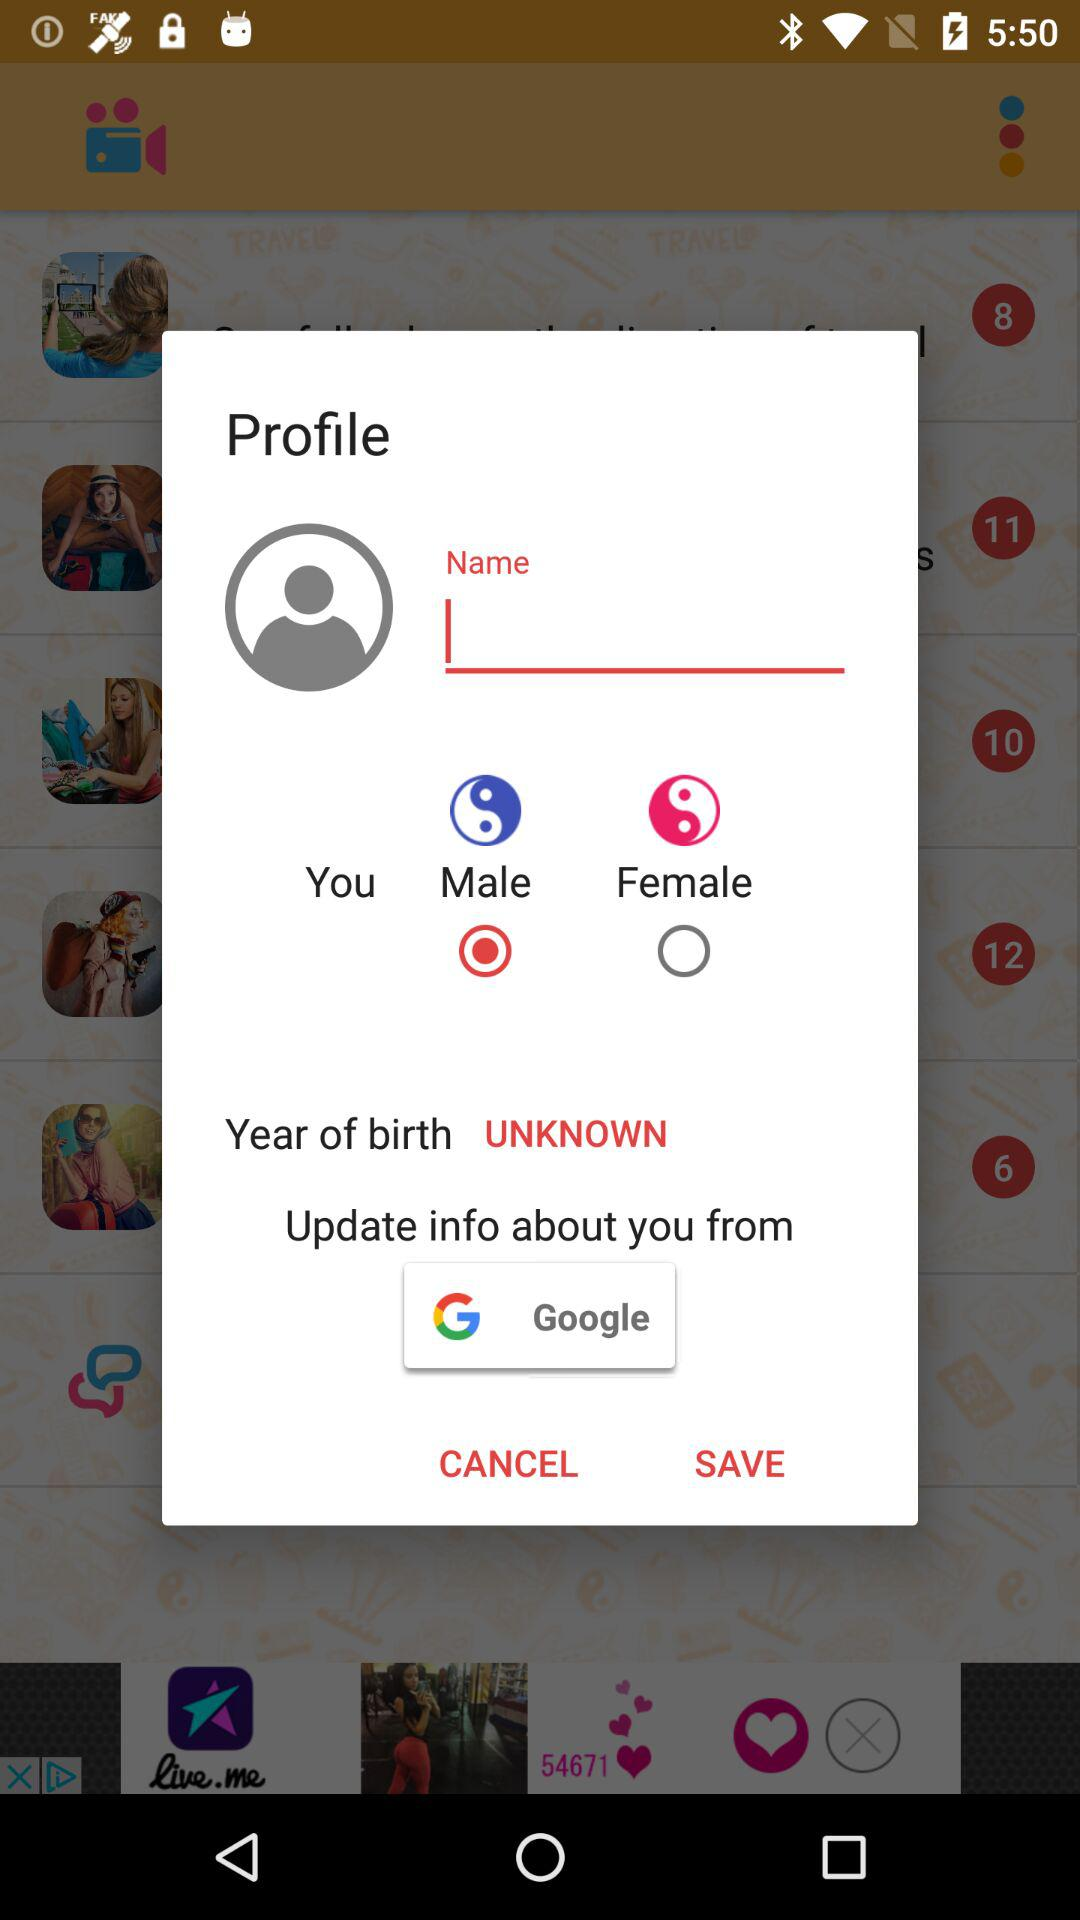What is the year of birth? The year of birth is unknown. 